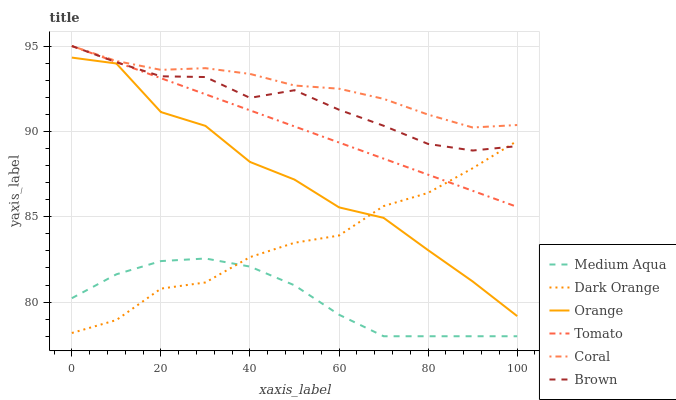Does Medium Aqua have the minimum area under the curve?
Answer yes or no. Yes. Does Coral have the maximum area under the curve?
Answer yes or no. Yes. Does Dark Orange have the minimum area under the curve?
Answer yes or no. No. Does Dark Orange have the maximum area under the curve?
Answer yes or no. No. Is Tomato the smoothest?
Answer yes or no. Yes. Is Orange the roughest?
Answer yes or no. Yes. Is Dark Orange the smoothest?
Answer yes or no. No. Is Dark Orange the roughest?
Answer yes or no. No. Does Medium Aqua have the lowest value?
Answer yes or no. Yes. Does Dark Orange have the lowest value?
Answer yes or no. No. Does Coral have the highest value?
Answer yes or no. Yes. Does Dark Orange have the highest value?
Answer yes or no. No. Is Orange less than Coral?
Answer yes or no. Yes. Is Brown greater than Medium Aqua?
Answer yes or no. Yes. Does Dark Orange intersect Medium Aqua?
Answer yes or no. Yes. Is Dark Orange less than Medium Aqua?
Answer yes or no. No. Is Dark Orange greater than Medium Aqua?
Answer yes or no. No. Does Orange intersect Coral?
Answer yes or no. No. 